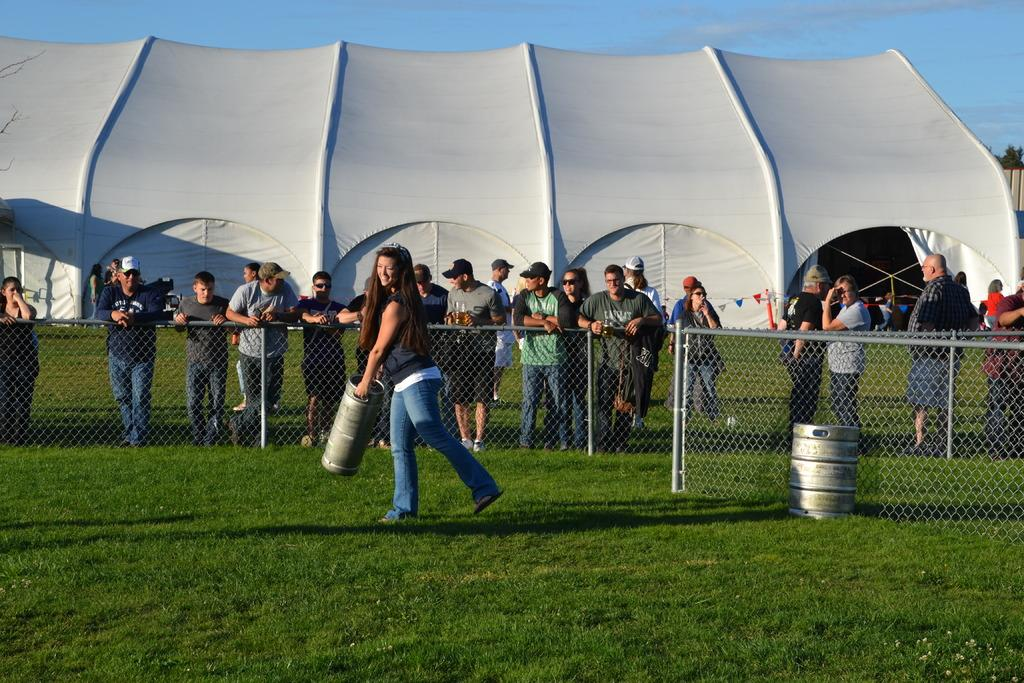Who is present in the image? There is a woman in the picture. What is the woman holding in the image? The woman is holding an object. What can be seen in the background of the picture? There is a fence and a tent in the background of the picture. How is the sky depicted in the image? The sky is clear in the image. What type of rice can be seen growing near the tent in the image? There is no rice visible in the image, and no indication of any agricultural activity. 